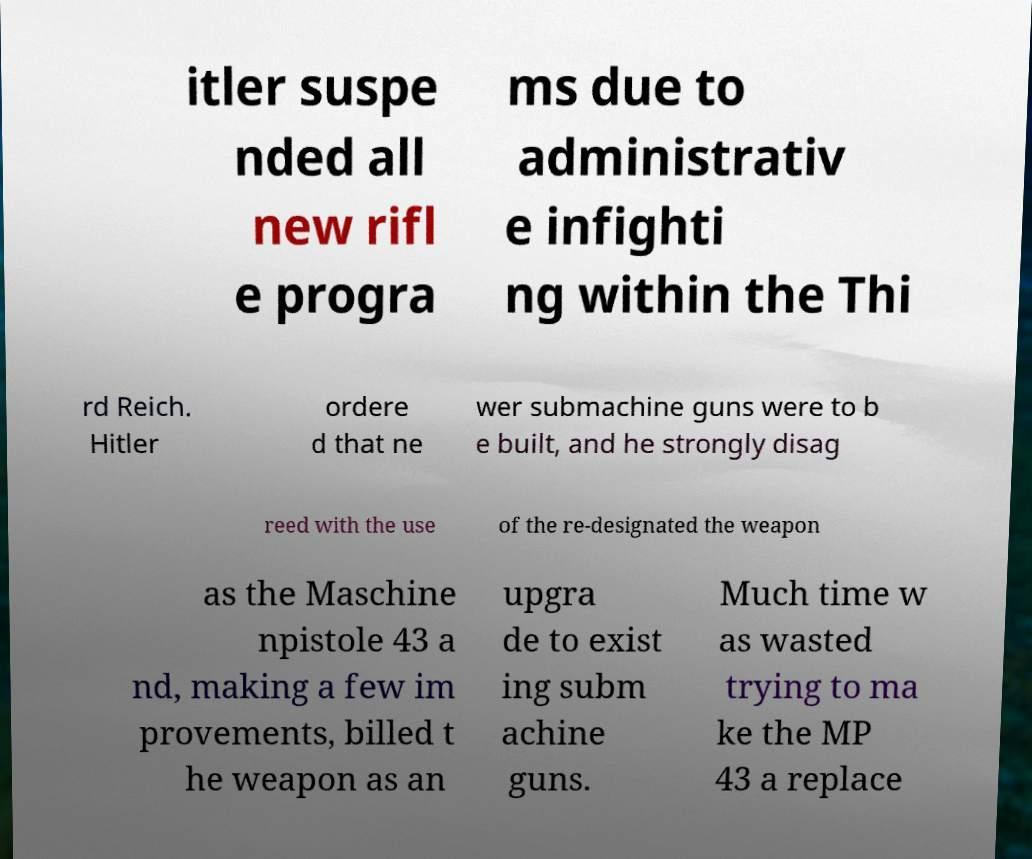Could you extract and type out the text from this image? itler suspe nded all new rifl e progra ms due to administrativ e infighti ng within the Thi rd Reich. Hitler ordere d that ne wer submachine guns were to b e built, and he strongly disag reed with the use of the re-designated the weapon as the Maschine npistole 43 a nd, making a few im provements, billed t he weapon as an upgra de to exist ing subm achine guns. Much time w as wasted trying to ma ke the MP 43 a replace 